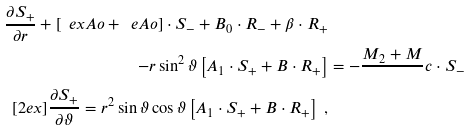<formula> <loc_0><loc_0><loc_500><loc_500>\frac { \partial S _ { + } } { \partial r } + \left [ \ e x A o + \ e A o \right ] \cdot S _ { - } + B _ { 0 } \cdot R _ { - } + \beta \cdot R _ { + } & \\ - r \sin ^ { 2 } \vartheta \left [ A _ { 1 } \cdot S _ { + } + B \cdot R _ { + } \right ] & = - \frac { M _ { 2 } + M } { } c \cdot S _ { - } \\ [ 2 e x ] \frac { \partial S _ { + } } { \partial \vartheta } = r ^ { 2 } \sin \vartheta \cos \vartheta \left [ A _ { 1 } \cdot S _ { + } + B \cdot R _ { + } \right ] \ ,</formula> 